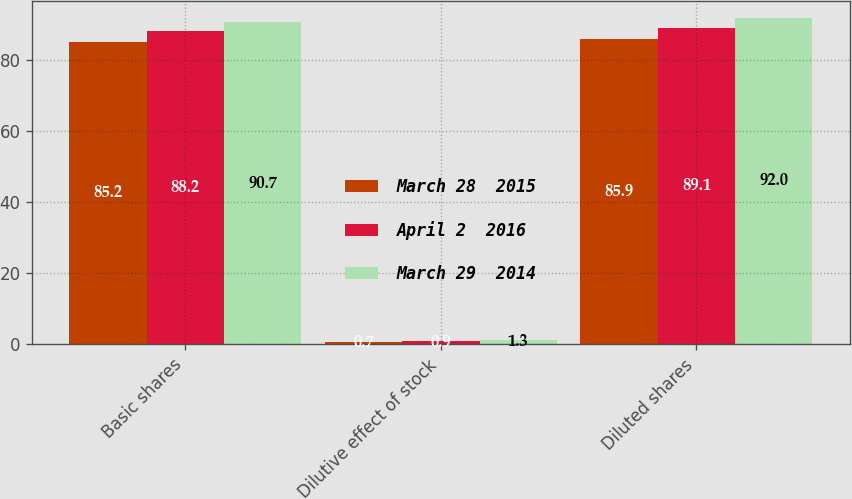Convert chart. <chart><loc_0><loc_0><loc_500><loc_500><stacked_bar_chart><ecel><fcel>Basic shares<fcel>Dilutive effect of stock<fcel>Diluted shares<nl><fcel>March 28  2015<fcel>85.2<fcel>0.7<fcel>85.9<nl><fcel>April 2  2016<fcel>88.2<fcel>0.9<fcel>89.1<nl><fcel>March 29  2014<fcel>90.7<fcel>1.3<fcel>92<nl></chart> 